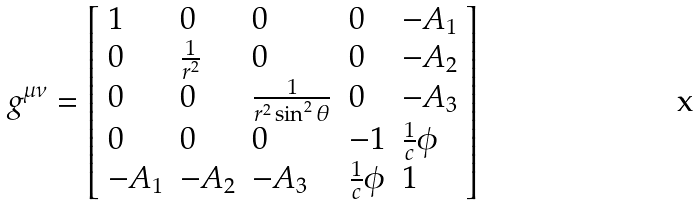Convert formula to latex. <formula><loc_0><loc_0><loc_500><loc_500>g ^ { \mu \nu } = \left [ \begin{array} { l l l l l } 1 & 0 & 0 & 0 & - A _ { 1 } \\ 0 & \frac { 1 } { r ^ { 2 } } & 0 & 0 & - A _ { 2 } \\ 0 & 0 & \frac { 1 } { r ^ { 2 } \sin ^ { 2 } \theta } & 0 & - A _ { 3 } \\ 0 & 0 & 0 & - 1 & \frac { 1 } { c } \phi \\ - A _ { 1 } & - A _ { 2 } & - A _ { 3 } & \frac { 1 } { c } \phi & 1 \end{array} \right ]</formula> 